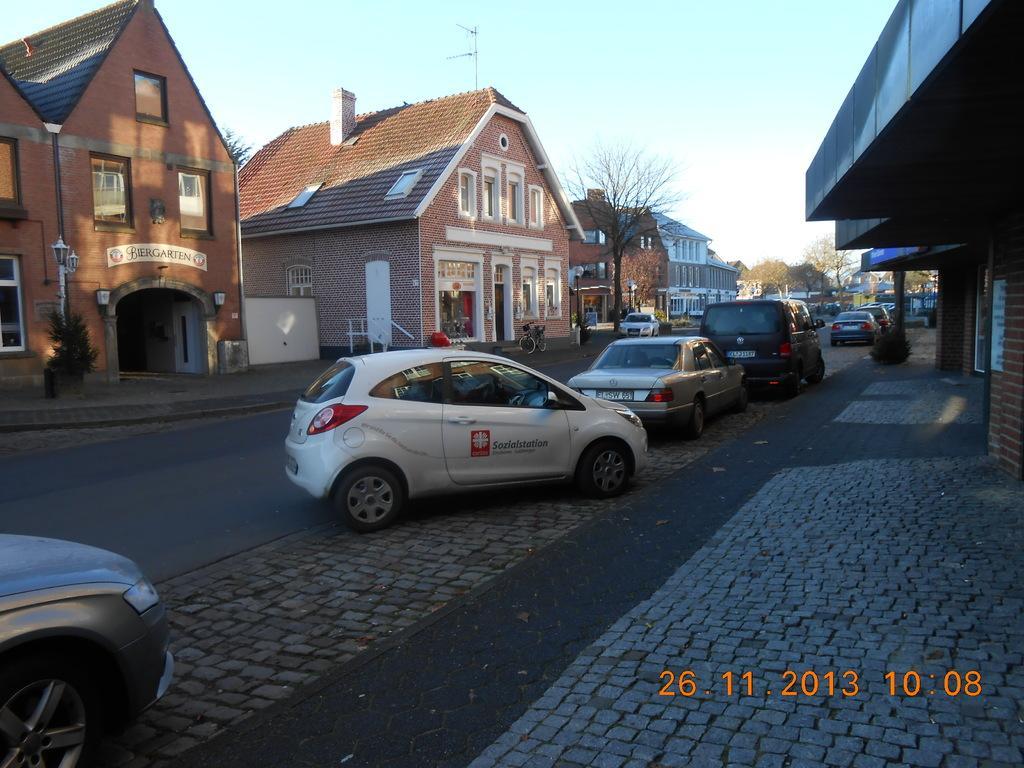In one or two sentences, can you explain what this image depicts? In the picture we can see a street with a road near to it we can see a path with some cars are parked near it and on the either sides of the path we can see house buildings with door, windows and in the background we can see some trees, poles and sky. 